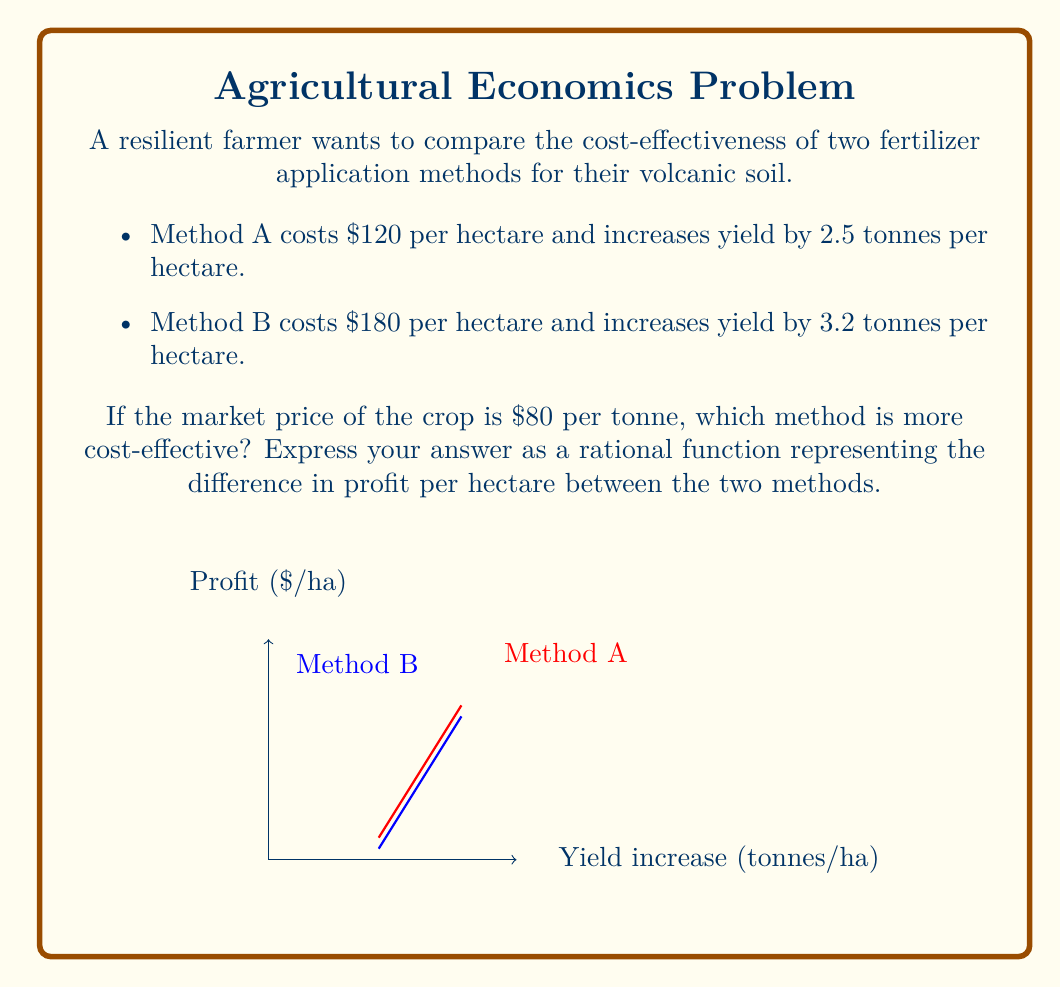Solve this math problem. Let's approach this step-by-step:

1) First, let's define our variables:
   Let $x$ be the yield increase in tonnes per hectare.

2) For Method A:
   - Cost: $120 per hectare
   - Yield increase: 2.5 tonnes per hectare
   - Revenue: $80 * 2.5 = $200 per hectare
   - Profit: $200 - $120 = $80 per hectare

3) For Method B:
   - Cost: $180 per hectare
   - Yield increase: 3.2 tonnes per hectare
   - Revenue: $80 * 3.2 = $256 per hectare
   - Profit: $256 - $180 = $76 per hectare

4) To compare cost-effectiveness, we need to find the difference in profit:
   Difference = Profit(Method A) - Profit(Method B)
               = $80 - $76 = $4 per hectare

5) To express this as a rational function, we need to consider the yield increase as a variable:
   - Profit function for Method A: $P_A(x) = 80x - 120$
   - Profit function for Method B: $P_B(x) = 80x - 180$

6) The difference in profit as a rational function:
   $$D(x) = P_A(x) - P_B(x) = (80x - 120) - (80x - 180) = 60$$

7) This function simplifies to a constant, which means the difference in profit is always $60 regardless of the yield increase.

8) However, we're asked about the specific scenario given. So we need to evaluate this at the given yield increases:
   $$D(3.2) - D(2.5) = 60 - 60 = 0$$

Therefore, the difference in profit per hectare between the two methods is $0, meaning they are equally cost-effective in this scenario.
Answer: $0 